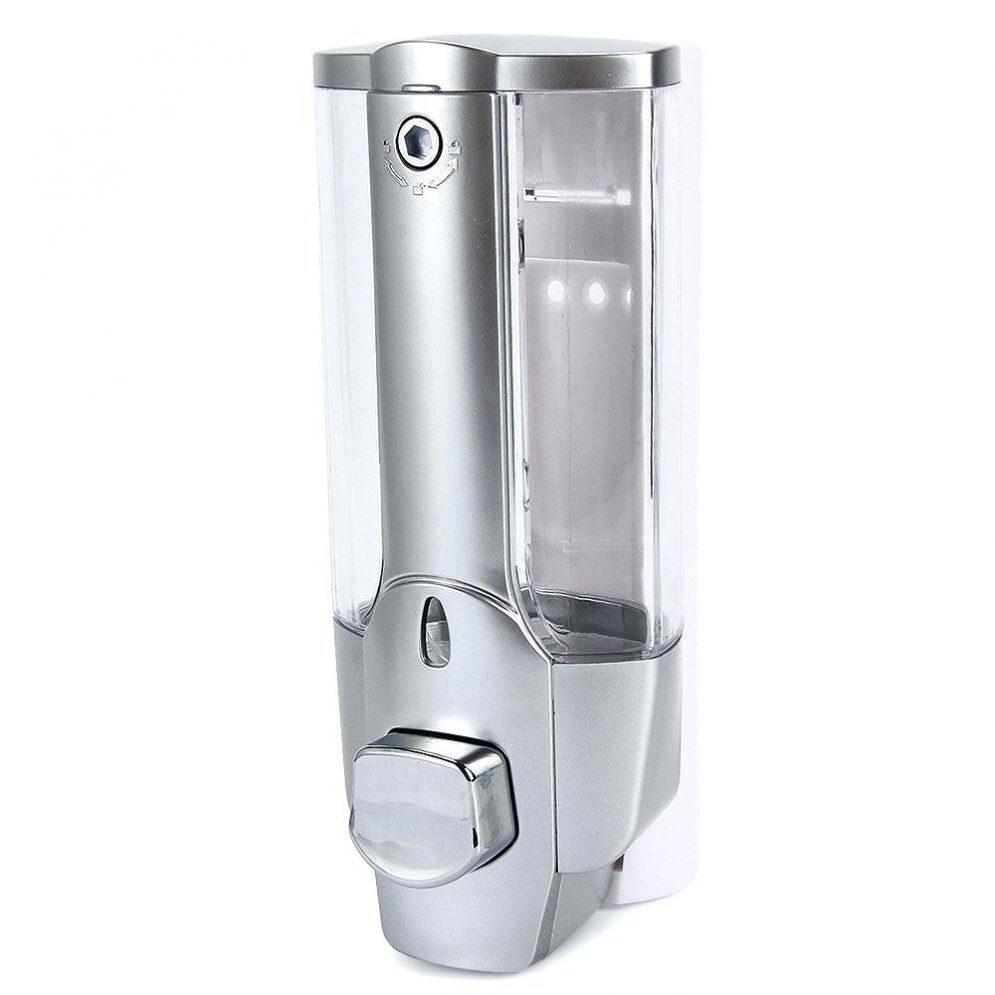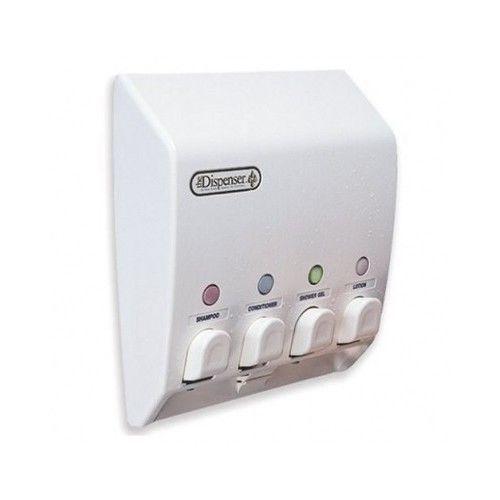The first image is the image on the left, the second image is the image on the right. For the images shown, is this caption "There is liquid filling at least five dispensers." true? Answer yes or no. No. The first image is the image on the left, the second image is the image on the right. For the images shown, is this caption "An image shows a trio of cylindrical dispensers that mount together, and one dispenses a white creamy-looking substance." true? Answer yes or no. No. 